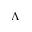<formula> <loc_0><loc_0><loc_500><loc_500>\Lambda</formula> 